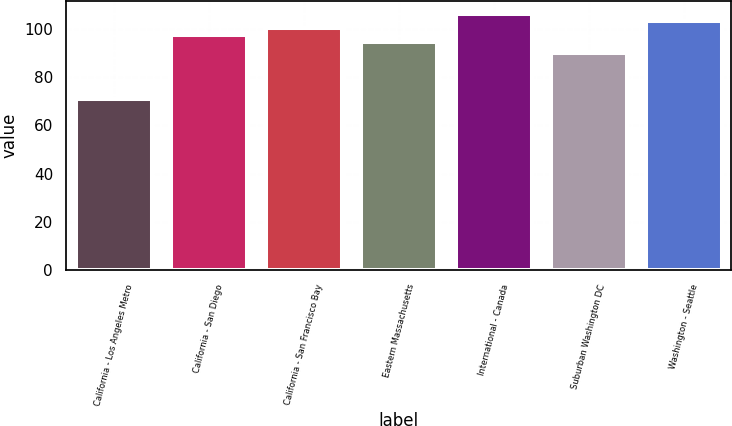<chart> <loc_0><loc_0><loc_500><loc_500><bar_chart><fcel>California - Los Angeles Metro<fcel>California - San Diego<fcel>California - San Francisco Bay<fcel>Eastern Massachusetts<fcel>International - Canada<fcel>Suburban Washington DC<fcel>Washington - Seattle<nl><fcel>70.8<fcel>97.62<fcel>100.54<fcel>94.7<fcel>106.38<fcel>90.1<fcel>103.46<nl></chart> 